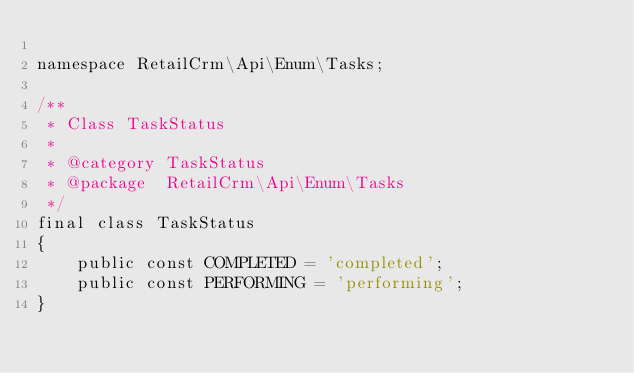<code> <loc_0><loc_0><loc_500><loc_500><_PHP_>
namespace RetailCrm\Api\Enum\Tasks;

/**
 * Class TaskStatus
 *
 * @category TaskStatus
 * @package  RetailCrm\Api\Enum\Tasks
 */
final class TaskStatus
{
    public const COMPLETED = 'completed';
    public const PERFORMING = 'performing';
}
</code> 